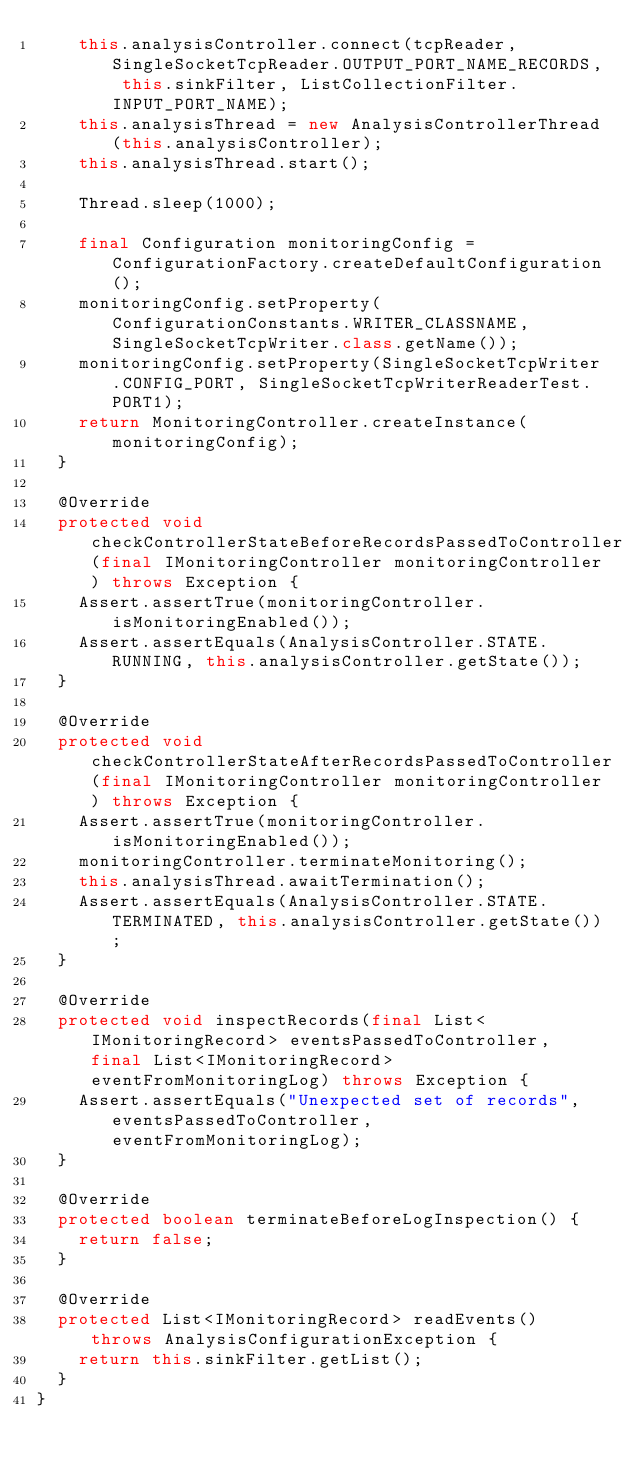<code> <loc_0><loc_0><loc_500><loc_500><_Java_>		this.analysisController.connect(tcpReader, SingleSocketTcpReader.OUTPUT_PORT_NAME_RECORDS, this.sinkFilter, ListCollectionFilter.INPUT_PORT_NAME);
		this.analysisThread = new AnalysisControllerThread(this.analysisController);
		this.analysisThread.start();

		Thread.sleep(1000);

		final Configuration monitoringConfig = ConfigurationFactory.createDefaultConfiguration();
		monitoringConfig.setProperty(ConfigurationConstants.WRITER_CLASSNAME, SingleSocketTcpWriter.class.getName());
		monitoringConfig.setProperty(SingleSocketTcpWriter.CONFIG_PORT, SingleSocketTcpWriterReaderTest.PORT1);
		return MonitoringController.createInstance(monitoringConfig);
	}

	@Override
	protected void checkControllerStateBeforeRecordsPassedToController(final IMonitoringController monitoringController) throws Exception {
		Assert.assertTrue(monitoringController.isMonitoringEnabled());
		Assert.assertEquals(AnalysisController.STATE.RUNNING, this.analysisController.getState());
	}

	@Override
	protected void checkControllerStateAfterRecordsPassedToController(final IMonitoringController monitoringController) throws Exception {
		Assert.assertTrue(monitoringController.isMonitoringEnabled());
		monitoringController.terminateMonitoring();
		this.analysisThread.awaitTermination();
		Assert.assertEquals(AnalysisController.STATE.TERMINATED, this.analysisController.getState());
	}

	@Override
	protected void inspectRecords(final List<IMonitoringRecord> eventsPassedToController, final List<IMonitoringRecord> eventFromMonitoringLog) throws Exception {
		Assert.assertEquals("Unexpected set of records", eventsPassedToController, eventFromMonitoringLog);
	}

	@Override
	protected boolean terminateBeforeLogInspection() {
		return false;
	}

	@Override
	protected List<IMonitoringRecord> readEvents() throws AnalysisConfigurationException {
		return this.sinkFilter.getList();
	}
}
</code> 